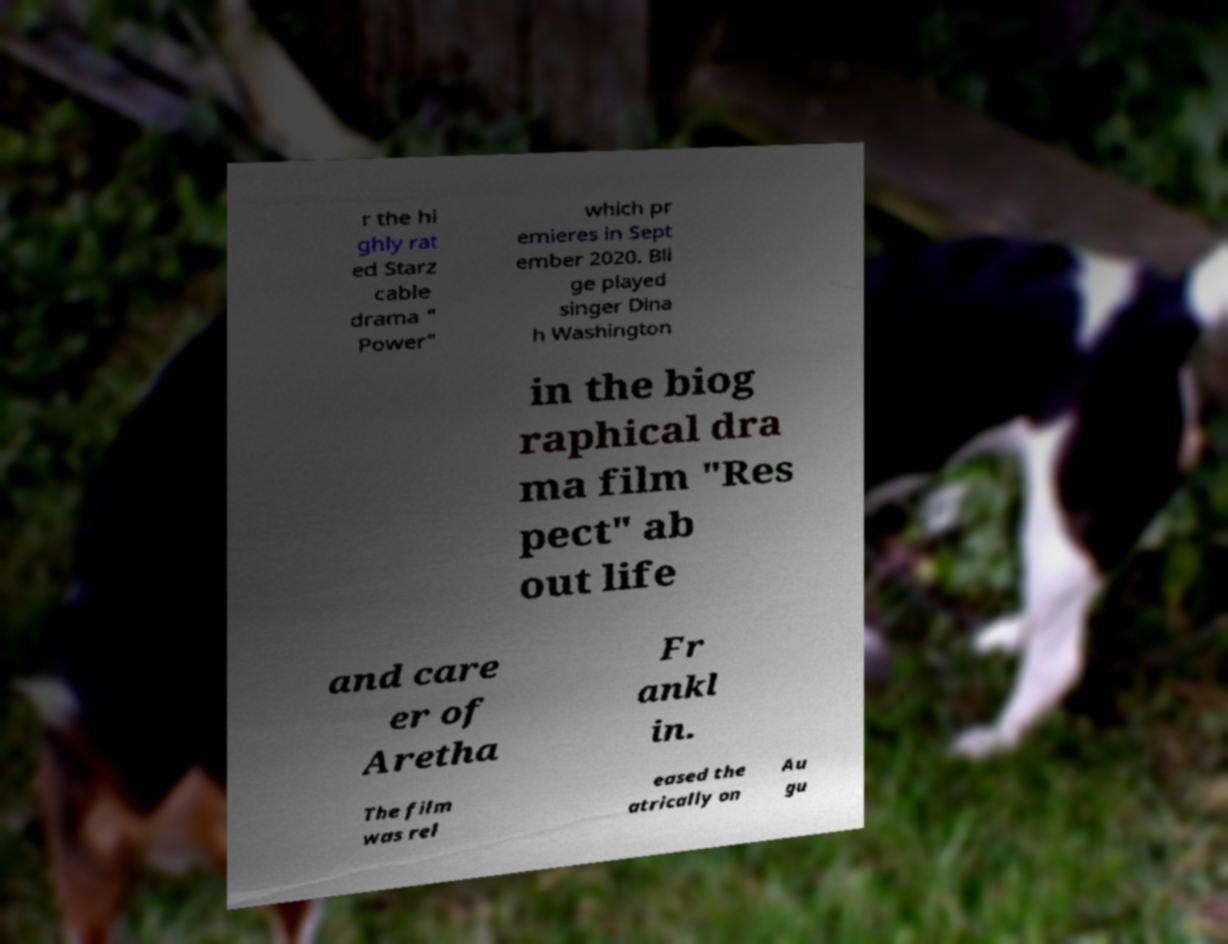Can you read and provide the text displayed in the image?This photo seems to have some interesting text. Can you extract and type it out for me? r the hi ghly rat ed Starz cable drama " Power" which pr emieres in Sept ember 2020. Bli ge played singer Dina h Washington in the biog raphical dra ma film "Res pect" ab out life and care er of Aretha Fr ankl in. The film was rel eased the atrically on Au gu 